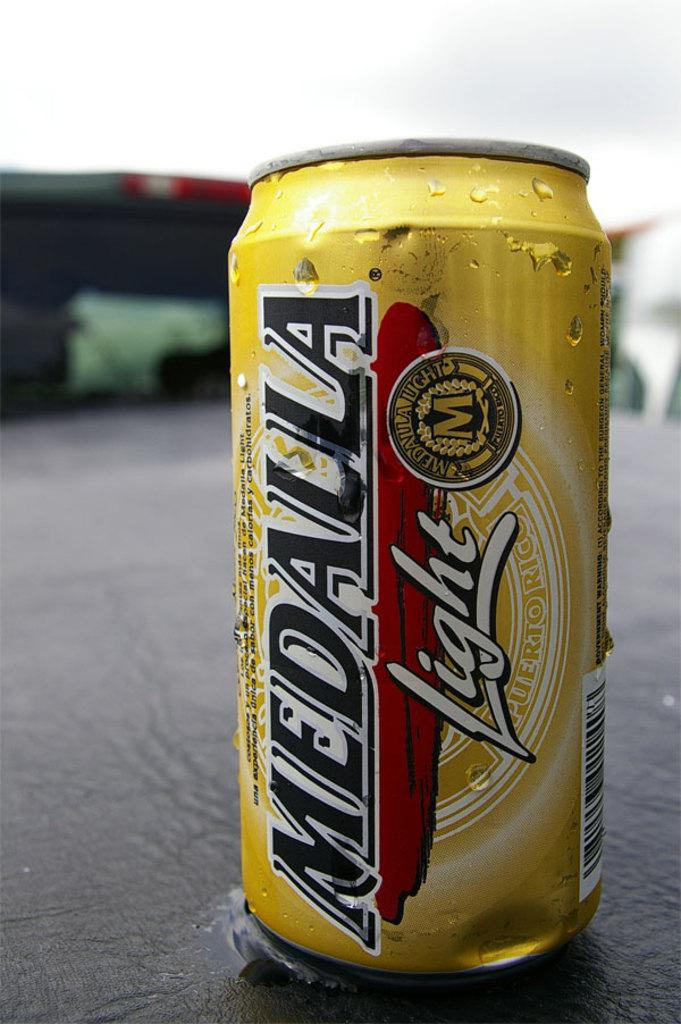What is the color of the tin in the image? The tin in the image has a golden color. What can be found on the surface of the tin? The tin has text, designs, and a barcode printed on it. Where is the tin located in the image? The tin is on a table. How would you describe the background of the image? The background of the image is blurred. Can you see any mines in the image? There are no mines present in the image; it features a golden color tin on a table. How many roses are depicted on the tin in the image? There are no roses depicted on the tin in the image; it has text, designs, and a barcode printed on it. 